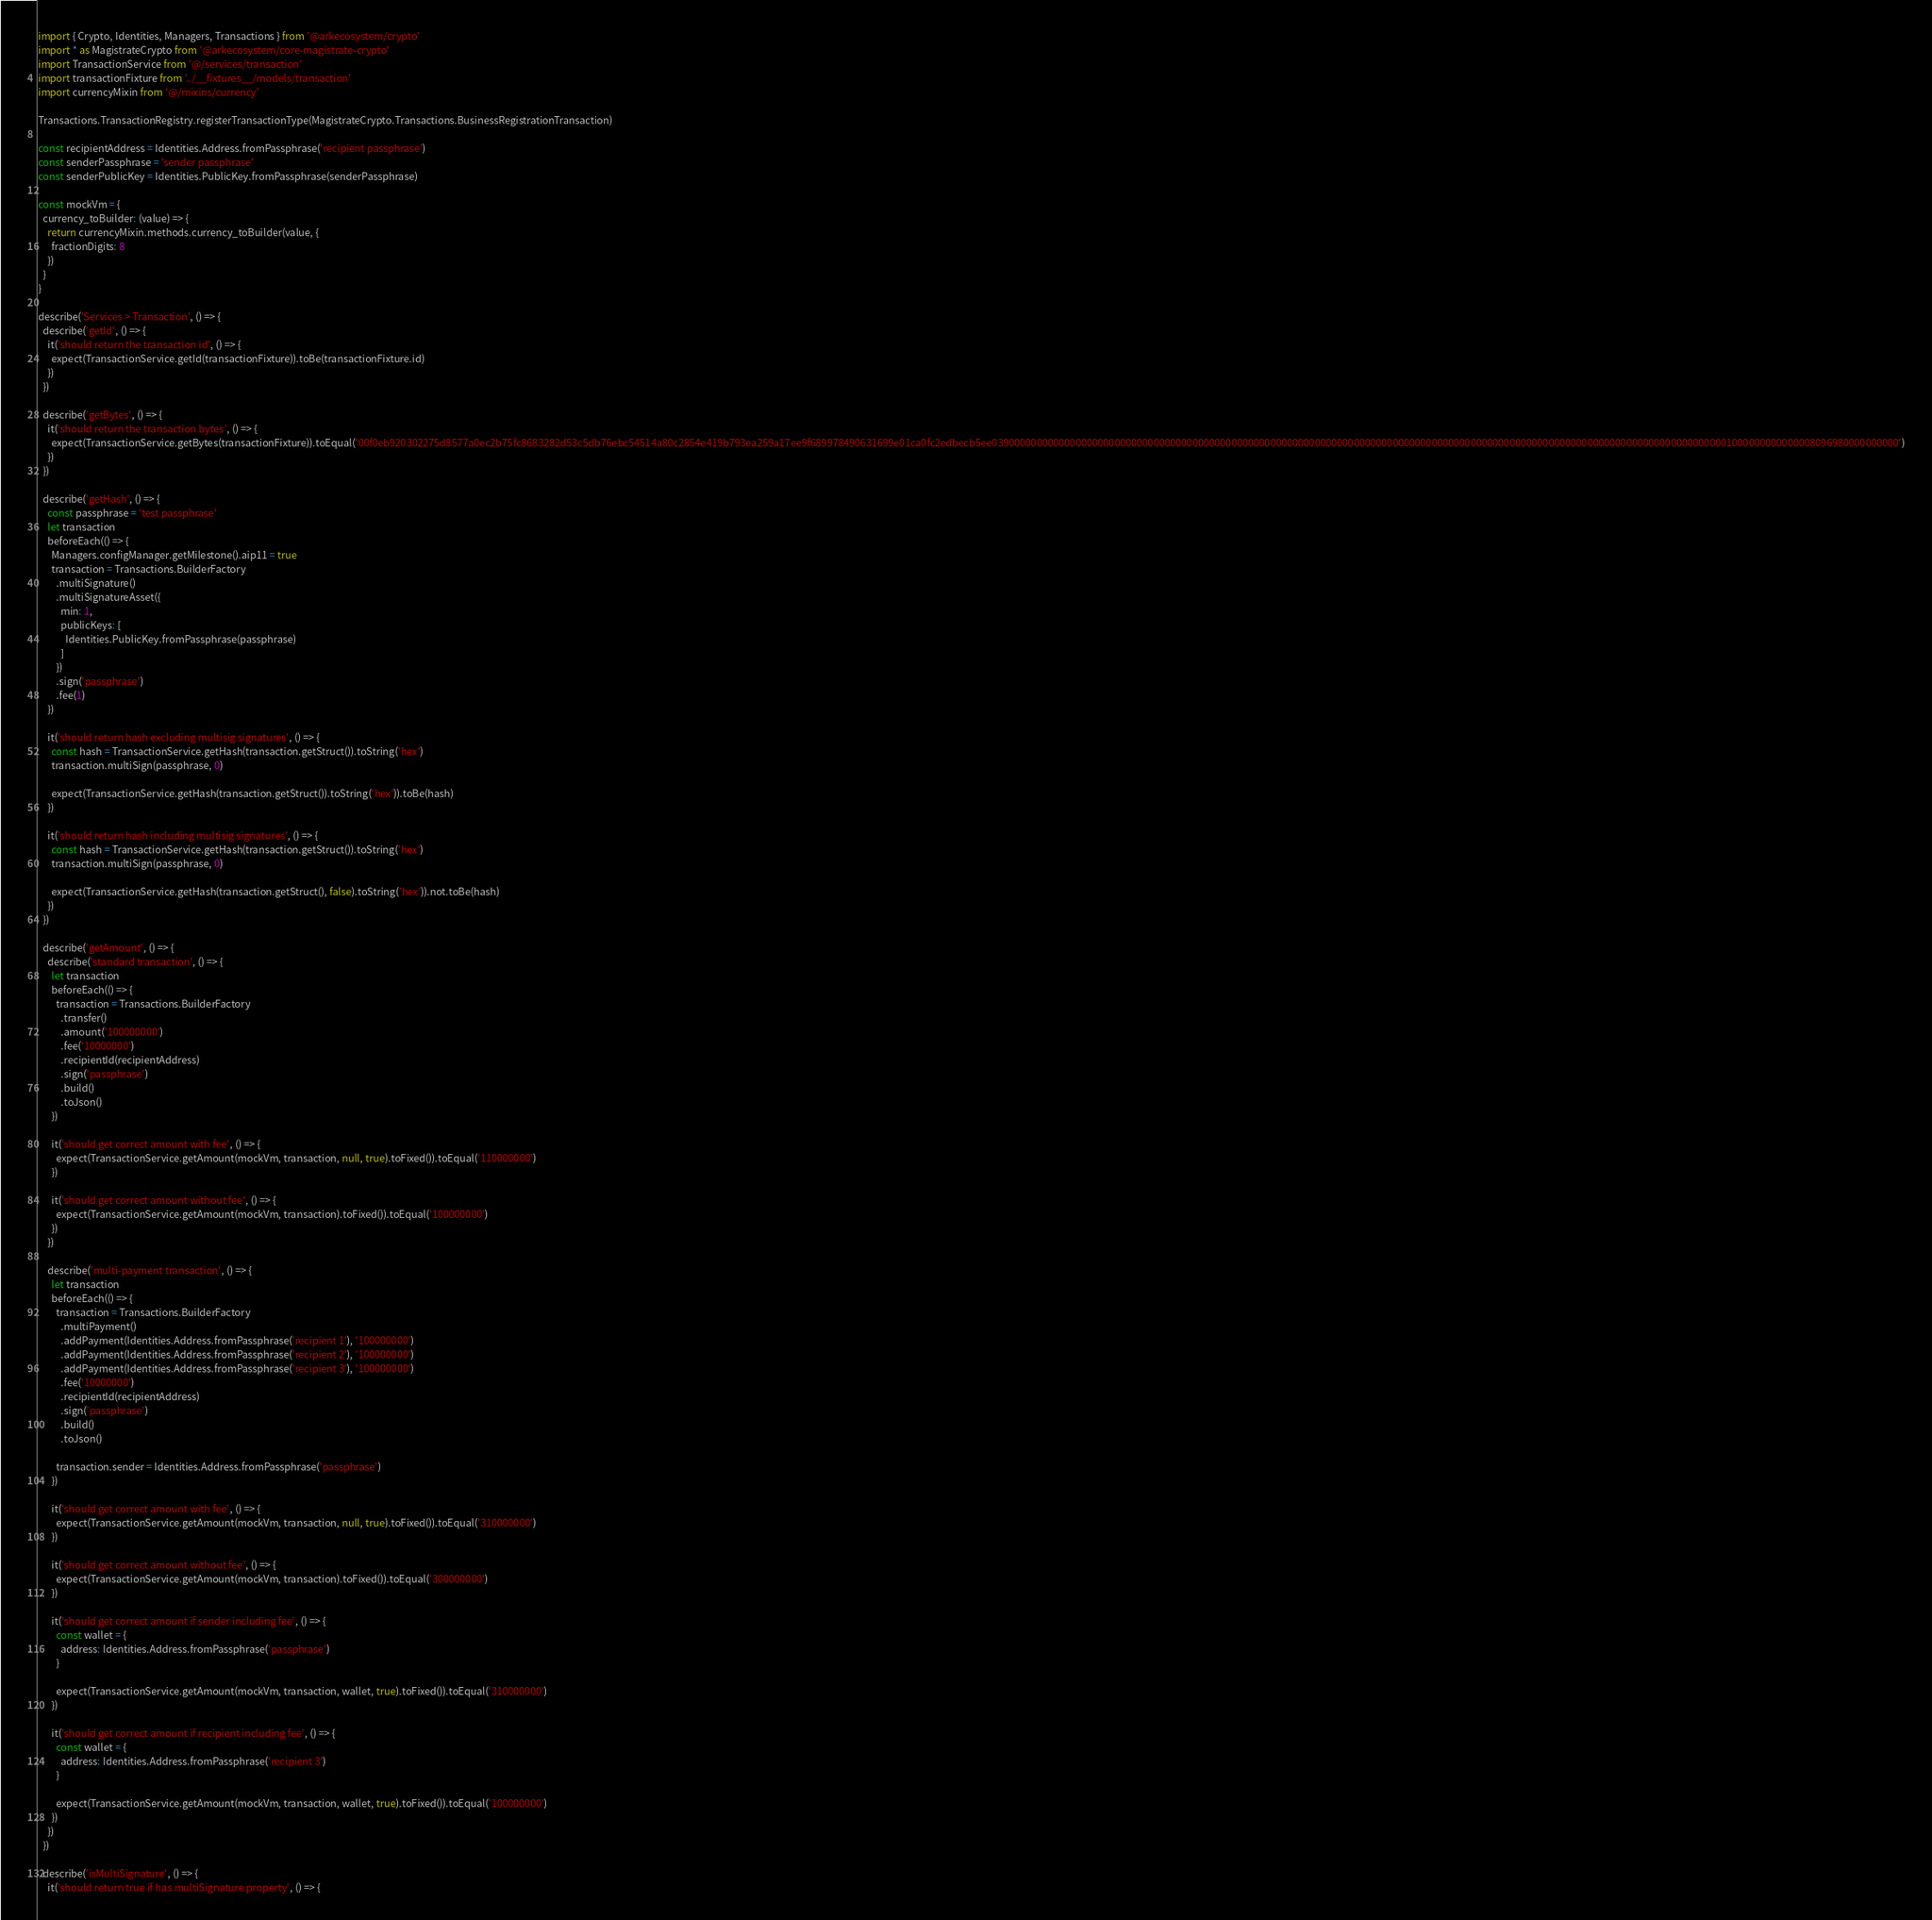<code> <loc_0><loc_0><loc_500><loc_500><_JavaScript_>import { Crypto, Identities, Managers, Transactions } from '@arkecosystem/crypto'
import * as MagistrateCrypto from '@arkecosystem/core-magistrate-crypto'
import TransactionService from '@/services/transaction'
import transactionFixture from '../__fixtures__/models/transaction'
import currencyMixin from '@/mixins/currency'

Transactions.TransactionRegistry.registerTransactionType(MagistrateCrypto.Transactions.BusinessRegistrationTransaction)

const recipientAddress = Identities.Address.fromPassphrase('recipient passphrase')
const senderPassphrase = 'sender passphrase'
const senderPublicKey = Identities.PublicKey.fromPassphrase(senderPassphrase)

const mockVm = {
  currency_toBuilder: (value) => {
    return currencyMixin.methods.currency_toBuilder(value, {
      fractionDigits: 8
    })
  }
}

describe('Services > Transaction', () => {
  describe('getId', () => {
    it('should return the transaction id', () => {
      expect(TransactionService.getId(transactionFixture)).toBe(transactionFixture.id)
    })
  })

  describe('getBytes', () => {
    it('should return the transaction bytes', () => {
      expect(TransactionService.getBytes(transactionFixture)).toEqual('00f0eb920302275d8577a0ec2b75fc8683282d53c5db76ebc54514a80c2854e419b793ea259a17ee9f689978490631699e01ca0fc2edbecb5ee0390000000000000000000000000000000000000000000000000000000000000000000000000000000000000000000000000000000000000000000000000000000001000000000000008096980000000000')
    })
  })

  describe('getHash', () => {
    const passphrase = 'test passphrase'
    let transaction
    beforeEach(() => {
      Managers.configManager.getMilestone().aip11 = true
      transaction = Transactions.BuilderFactory
        .multiSignature()
        .multiSignatureAsset({
          min: 1,
          publicKeys: [
            Identities.PublicKey.fromPassphrase(passphrase)
          ]
        })
        .sign('passphrase')
        .fee(1)
    })

    it('should return hash excluding multisig signatures', () => {
      const hash = TransactionService.getHash(transaction.getStruct()).toString('hex')
      transaction.multiSign(passphrase, 0)

      expect(TransactionService.getHash(transaction.getStruct()).toString('hex')).toBe(hash)
    })

    it('should return hash including multisig signatures', () => {
      const hash = TransactionService.getHash(transaction.getStruct()).toString('hex')
      transaction.multiSign(passphrase, 0)

      expect(TransactionService.getHash(transaction.getStruct(), false).toString('hex')).not.toBe(hash)
    })
  })

  describe('getAmount', () => {
    describe('standard transaction', () => {
      let transaction
      beforeEach(() => {
        transaction = Transactions.BuilderFactory
          .transfer()
          .amount('100000000')
          .fee('10000000')
          .recipientId(recipientAddress)
          .sign('passphrase')
          .build()
          .toJson()
      })

      it('should get correct amount with fee', () => {
        expect(TransactionService.getAmount(mockVm, transaction, null, true).toFixed()).toEqual('110000000')
      })

      it('should get correct amount without fee', () => {
        expect(TransactionService.getAmount(mockVm, transaction).toFixed()).toEqual('100000000')
      })
    })

    describe('multi-payment transaction', () => {
      let transaction
      beforeEach(() => {
        transaction = Transactions.BuilderFactory
          .multiPayment()
          .addPayment(Identities.Address.fromPassphrase('recipient 1'), '100000000')
          .addPayment(Identities.Address.fromPassphrase('recipient 2'), '100000000')
          .addPayment(Identities.Address.fromPassphrase('recipient 3'), '100000000')
          .fee('10000000')
          .recipientId(recipientAddress)
          .sign('passphrase')
          .build()
          .toJson()

        transaction.sender = Identities.Address.fromPassphrase('passphrase')
      })

      it('should get correct amount with fee', () => {
        expect(TransactionService.getAmount(mockVm, transaction, null, true).toFixed()).toEqual('310000000')
      })

      it('should get correct amount without fee', () => {
        expect(TransactionService.getAmount(mockVm, transaction).toFixed()).toEqual('300000000')
      })

      it('should get correct amount if sender including fee', () => {
        const wallet = {
          address: Identities.Address.fromPassphrase('passphrase')
        }

        expect(TransactionService.getAmount(mockVm, transaction, wallet, true).toFixed()).toEqual('310000000')
      })

      it('should get correct amount if recipient including fee', () => {
        const wallet = {
          address: Identities.Address.fromPassphrase('recipient 3')
        }

        expect(TransactionService.getAmount(mockVm, transaction, wallet, true).toFixed()).toEqual('100000000')
      })
    })
  })

  describe('isMultiSignature', () => {
    it('should return true if has multiSignature property', () => {</code> 